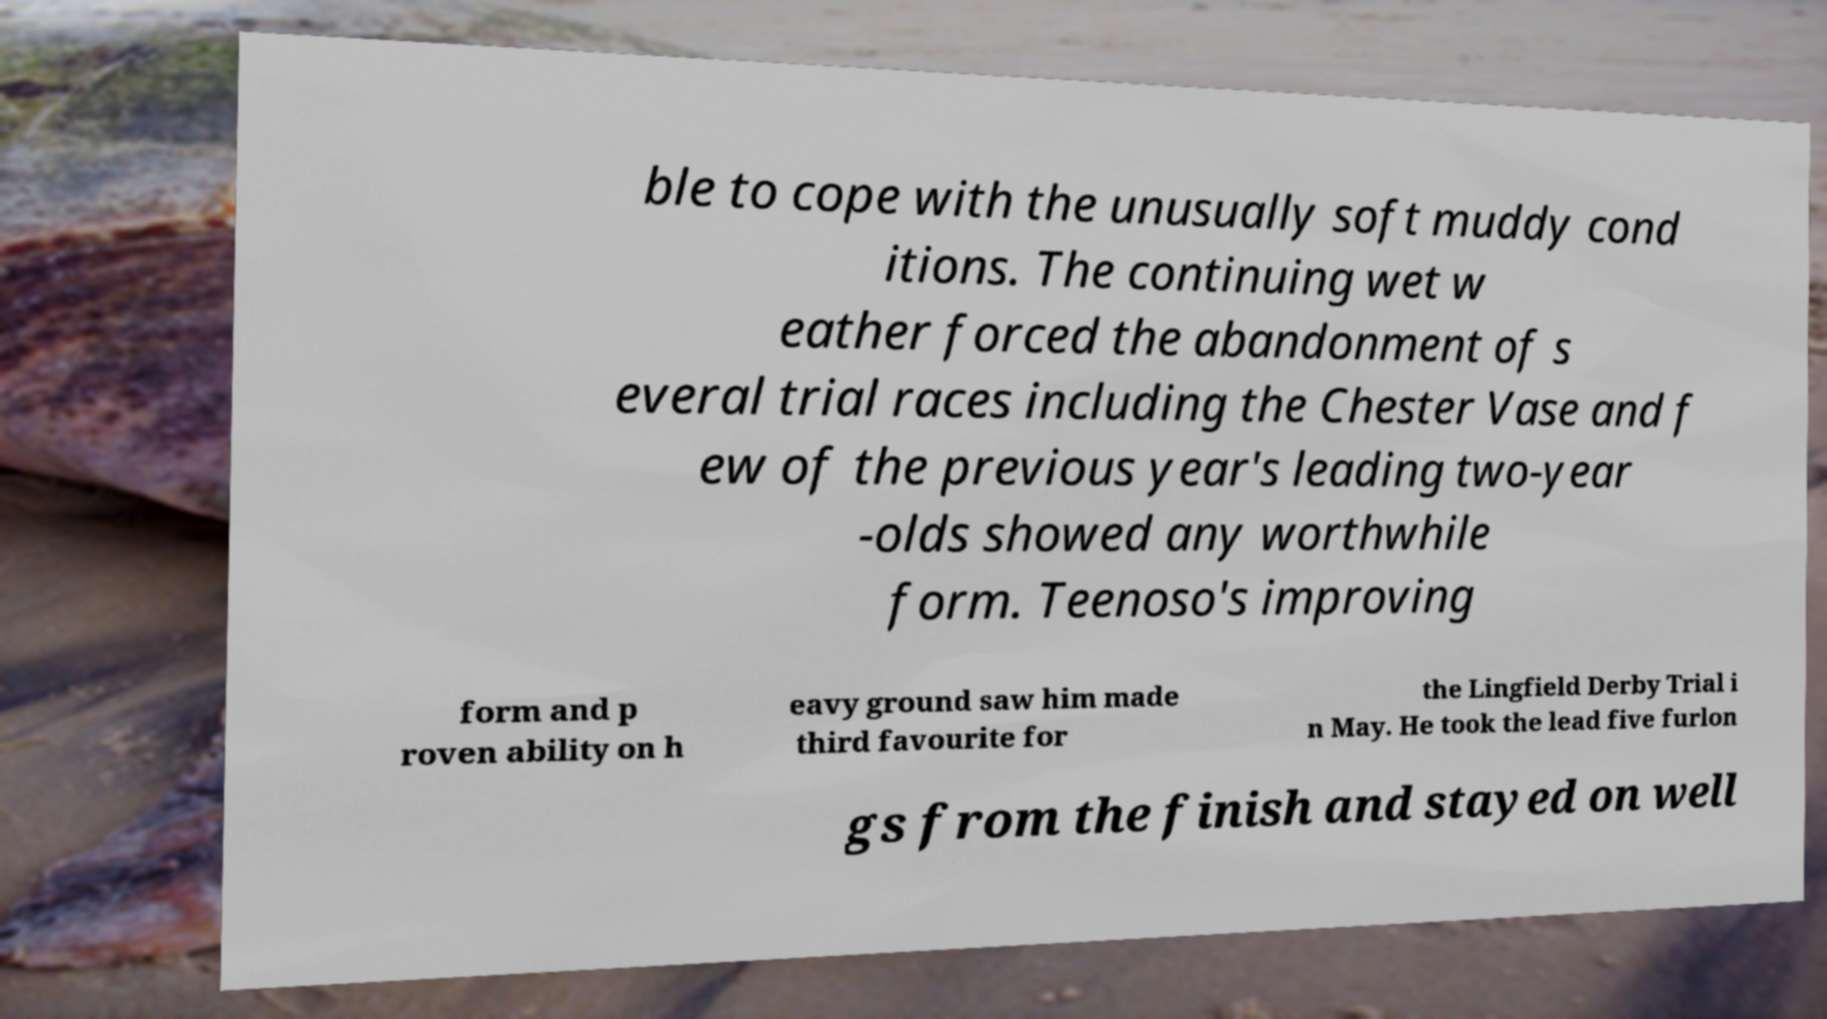Can you read and provide the text displayed in the image?This photo seems to have some interesting text. Can you extract and type it out for me? ble to cope with the unusually soft muddy cond itions. The continuing wet w eather forced the abandonment of s everal trial races including the Chester Vase and f ew of the previous year's leading two-year -olds showed any worthwhile form. Teenoso's improving form and p roven ability on h eavy ground saw him made third favourite for the Lingfield Derby Trial i n May. He took the lead five furlon gs from the finish and stayed on well 